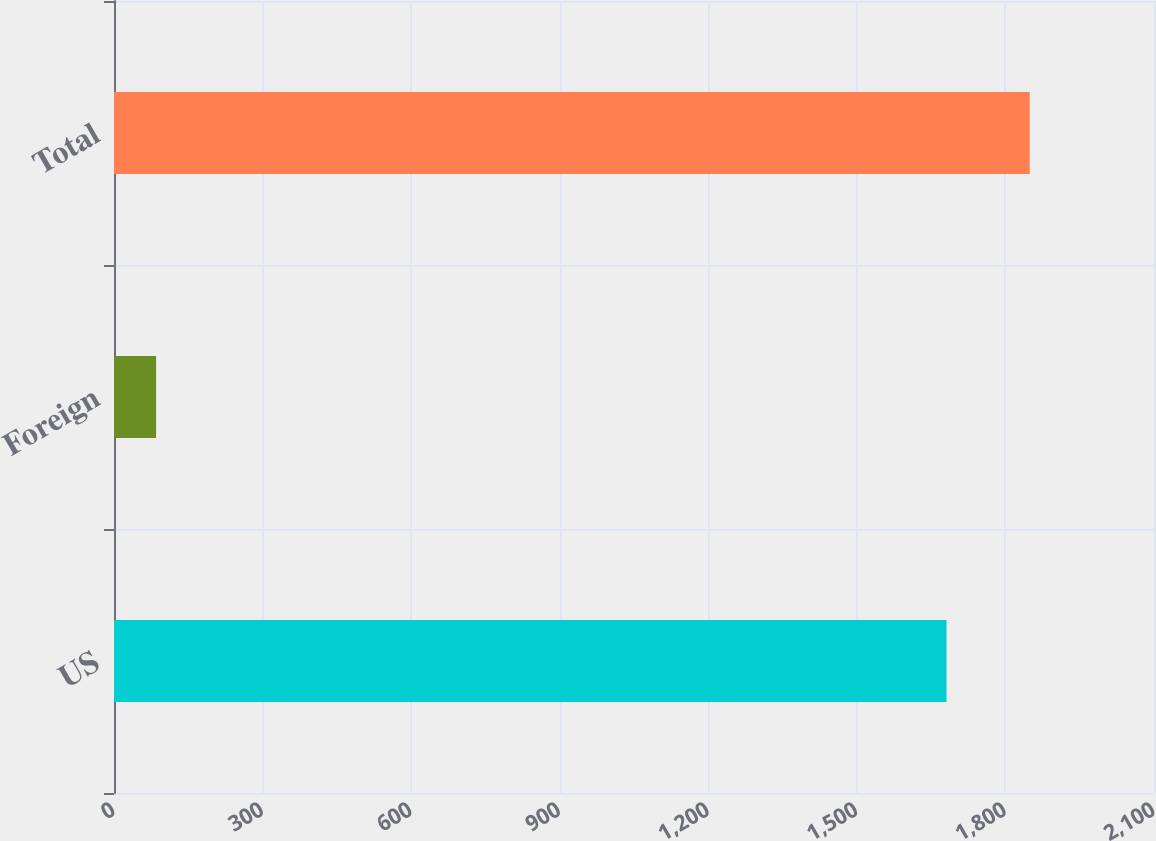<chart> <loc_0><loc_0><loc_500><loc_500><bar_chart><fcel>US<fcel>Foreign<fcel>Total<nl><fcel>1681<fcel>85<fcel>1849.1<nl></chart> 